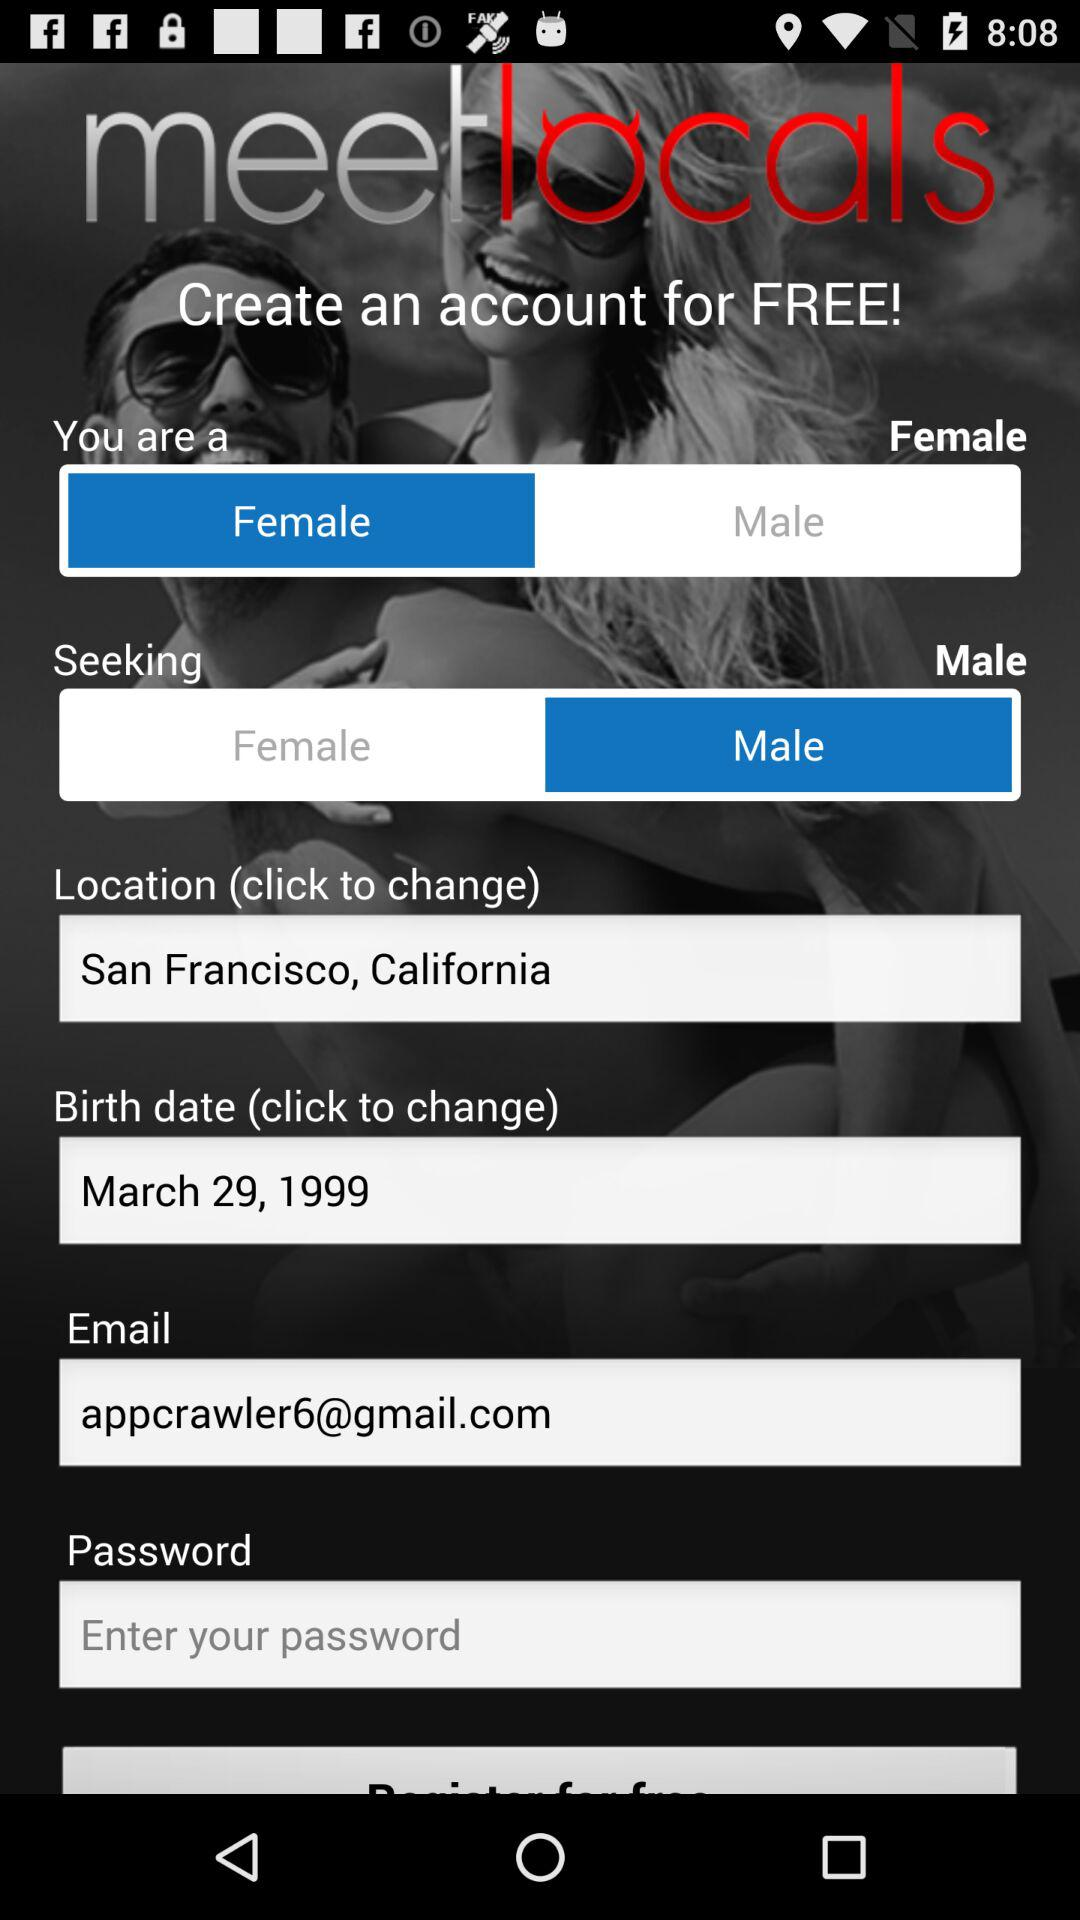What is the email address? The email address is appcrawler6@gmail.com. 